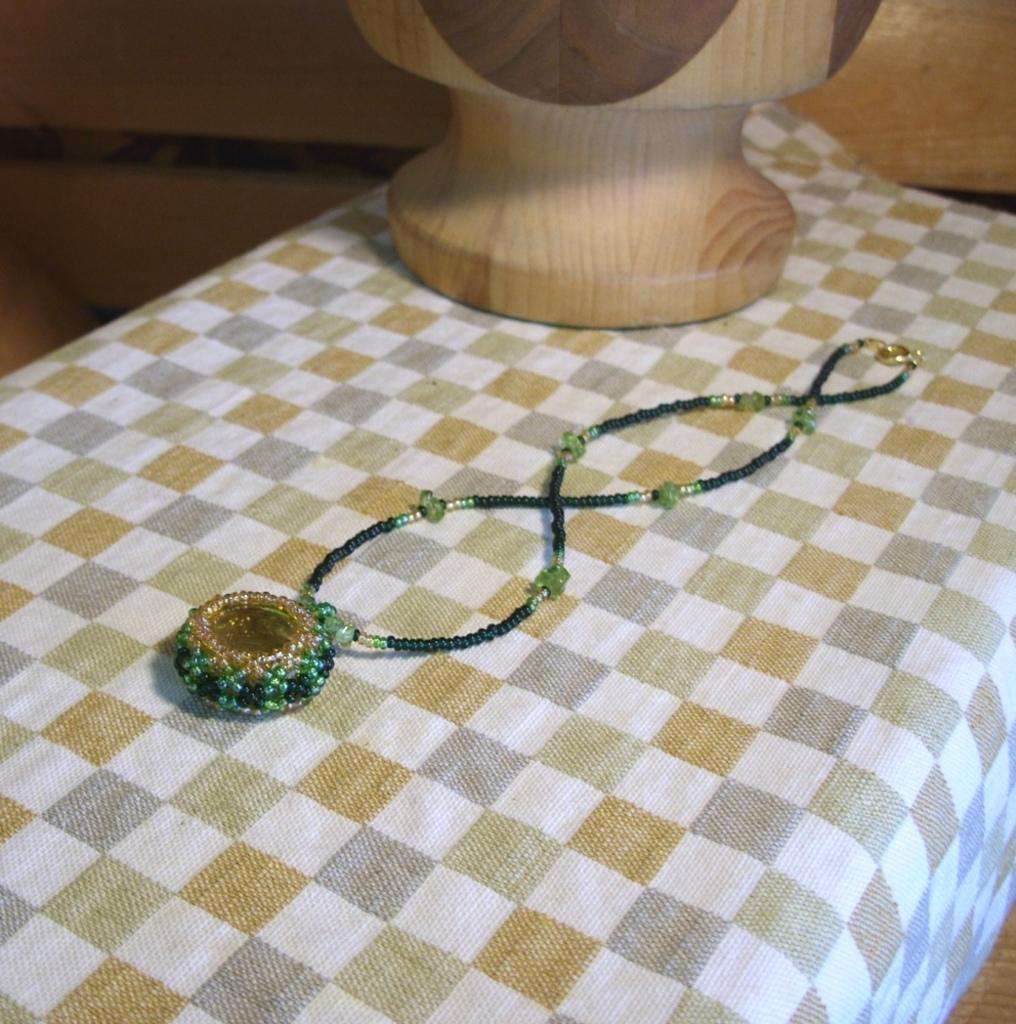Could you give a brief overview of what you see in this image? In this image there is a wooden structure and a locket with chain are placed on a table. 